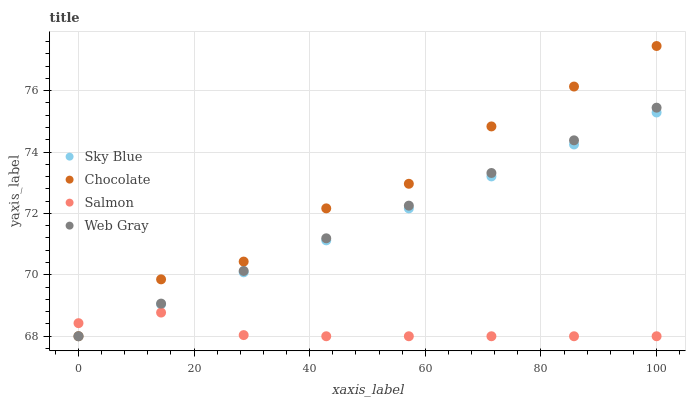Does Salmon have the minimum area under the curve?
Answer yes or no. Yes. Does Chocolate have the maximum area under the curve?
Answer yes or no. Yes. Does Web Gray have the minimum area under the curve?
Answer yes or no. No. Does Web Gray have the maximum area under the curve?
Answer yes or no. No. Is Sky Blue the smoothest?
Answer yes or no. Yes. Is Chocolate the roughest?
Answer yes or no. Yes. Is Web Gray the smoothest?
Answer yes or no. No. Is Web Gray the roughest?
Answer yes or no. No. Does Sky Blue have the lowest value?
Answer yes or no. Yes. Does Chocolate have the highest value?
Answer yes or no. Yes. Does Web Gray have the highest value?
Answer yes or no. No. Does Salmon intersect Chocolate?
Answer yes or no. Yes. Is Salmon less than Chocolate?
Answer yes or no. No. Is Salmon greater than Chocolate?
Answer yes or no. No. 